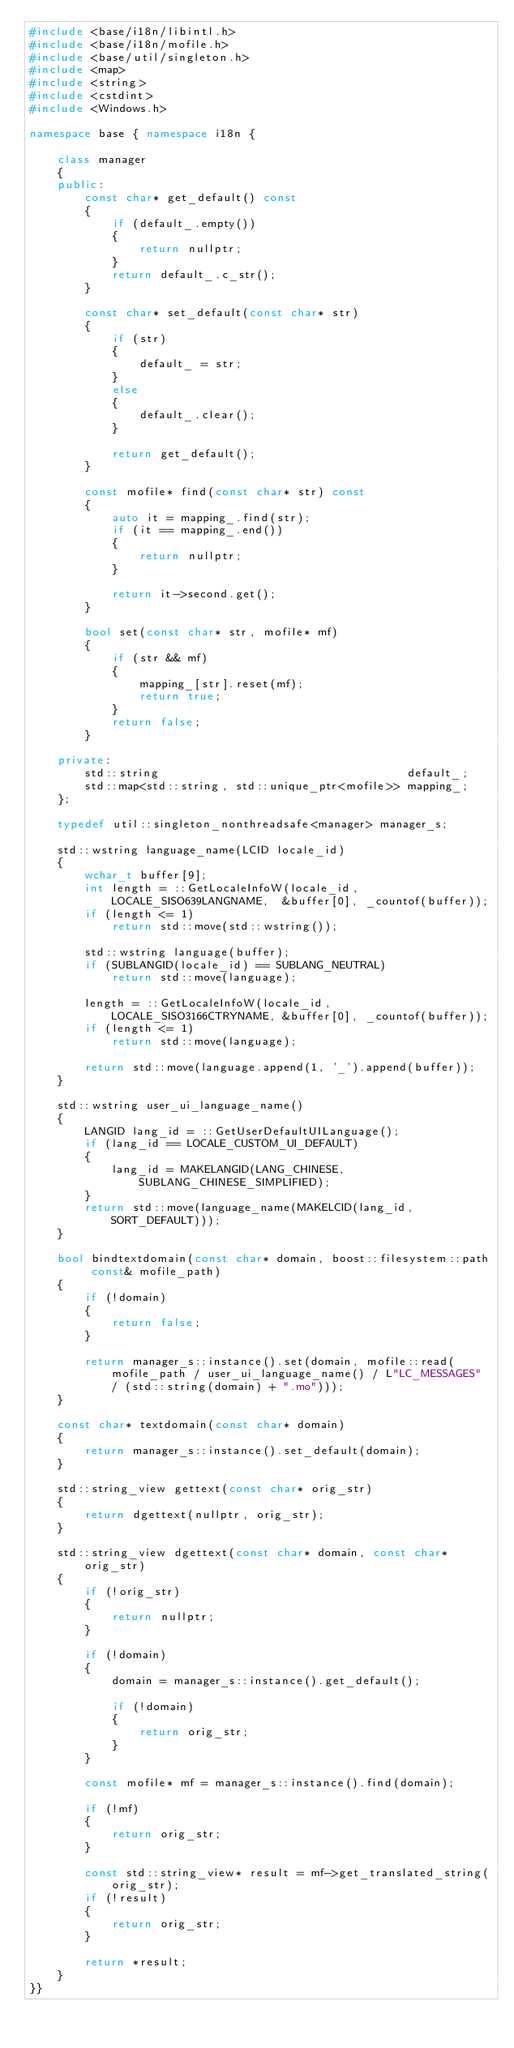<code> <loc_0><loc_0><loc_500><loc_500><_C++_>#include <base/i18n/libintl.h>
#include <base/i18n/mofile.h>
#include <base/util/singleton.h>
#include <map>
#include <string>
#include <cstdint>
#include <Windows.h>

namespace base { namespace i18n {

	class manager
	{
	public:
		const char* get_default() const
		{
			if (default_.empty())
			{
				return nullptr;
			}
			return default_.c_str();
		}

		const char* set_default(const char* str)
		{
			if (str)
			{
				default_ = str;
			}
			else
			{
				default_.clear();
			}

			return get_default();
		}

		const mofile* find(const char* str) const
		{
			auto it = mapping_.find(str);
			if (it == mapping_.end())
			{
				return nullptr;
			}

			return it->second.get();
		}

		bool set(const char* str, mofile* mf)
		{
			if (str && mf)
			{
				mapping_[str].reset(mf);
				return true;
			}
			return false;
		}

	private:
		std::string                                    default_;
		std::map<std::string, std::unique_ptr<mofile>> mapping_;
	};

	typedef util::singleton_nonthreadsafe<manager> manager_s;

	std::wstring language_name(LCID locale_id)
	{
		wchar_t buffer[9];
		int length = ::GetLocaleInfoW(locale_id, LOCALE_SISO639LANGNAME,  &buffer[0], _countof(buffer));
		if (length <= 1)
			return std::move(std::wstring());

		std::wstring language(buffer);
		if (SUBLANGID(locale_id) == SUBLANG_NEUTRAL)
			return std::move(language);

		length = ::GetLocaleInfoW(locale_id, LOCALE_SISO3166CTRYNAME, &buffer[0], _countof(buffer));
		if (length <= 1)
			return std::move(language);

		return std::move(language.append(1, '_').append(buffer));
	}

	std::wstring user_ui_language_name()
	{
		LANGID lang_id = ::GetUserDefaultUILanguage();
		if (lang_id == LOCALE_CUSTOM_UI_DEFAULT)
		{
			lang_id = MAKELANGID(LANG_CHINESE, SUBLANG_CHINESE_SIMPLIFIED);
		}
		return std::move(language_name(MAKELCID(lang_id, SORT_DEFAULT)));
	}

	bool bindtextdomain(const char* domain, boost::filesystem::path const& mofile_path)
	{
		if (!domain)
		{
			return false;
		}

		return manager_s::instance().set(domain, mofile::read(mofile_path / user_ui_language_name() / L"LC_MESSAGES" / (std::string(domain) + ".mo")));	
	}

	const char* textdomain(const char* domain)
	{
		return manager_s::instance().set_default(domain);
	}

	std::string_view gettext(const char* orig_str)
	{
		return dgettext(nullptr, orig_str);
	}

	std::string_view dgettext(const char* domain, const char* orig_str)
	{
		if (!orig_str)
		{
			return nullptr;
		}

		if (!domain)
		{
			domain = manager_s::instance().get_default();

			if (!domain)
			{
				return orig_str;
			}
		}

		const mofile* mf = manager_s::instance().find(domain);

		if (!mf)
		{
			return orig_str;
		}

		const std::string_view* result = mf->get_translated_string(orig_str);
		if (!result)
		{
			return orig_str;
		}

		return *result;
	}
}}
</code> 